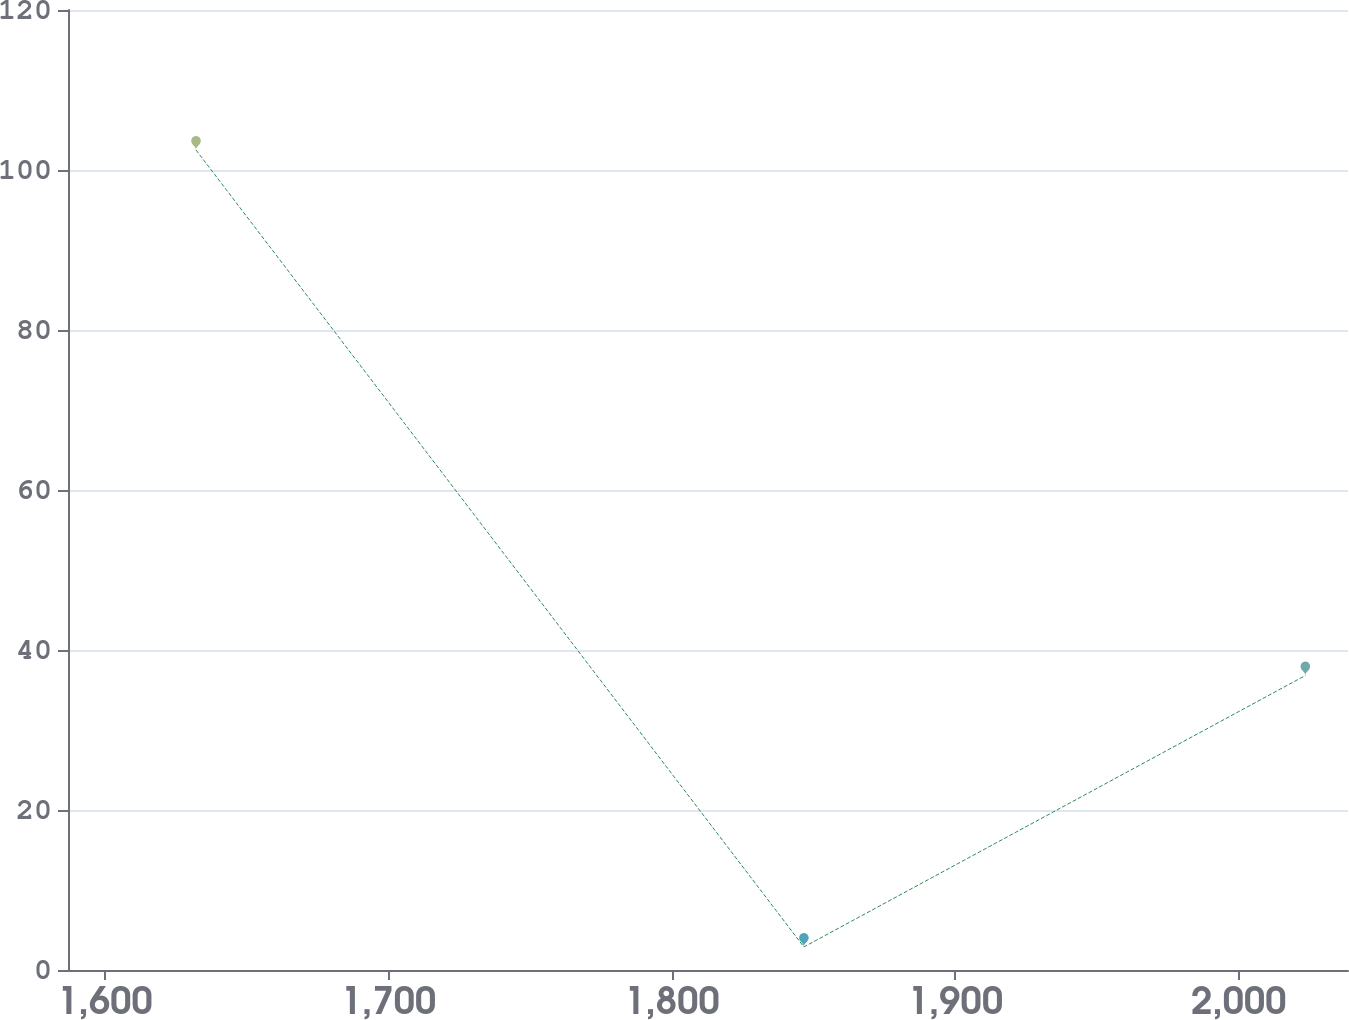Convert chart. <chart><loc_0><loc_0><loc_500><loc_500><line_chart><ecel><fcel>$ 11.1<nl><fcel>1632.14<fcel>102.5<nl><fcel>1846.59<fcel>2.88<nl><fcel>2023.49<fcel>36.81<nl><fcel>2083.69<fcel>342.13<nl></chart> 